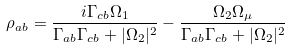Convert formula to latex. <formula><loc_0><loc_0><loc_500><loc_500>\rho _ { a b } = \frac { i \Gamma _ { c b } \Omega _ { 1 } } { \Gamma _ { a b } \Gamma _ { c b } + | \Omega _ { 2 } | ^ { 2 } } - \frac { \Omega _ { 2 } \Omega _ { \mu } } { \Gamma _ { a b } \Gamma _ { c b } + | \Omega _ { 2 } | ^ { 2 } }</formula> 